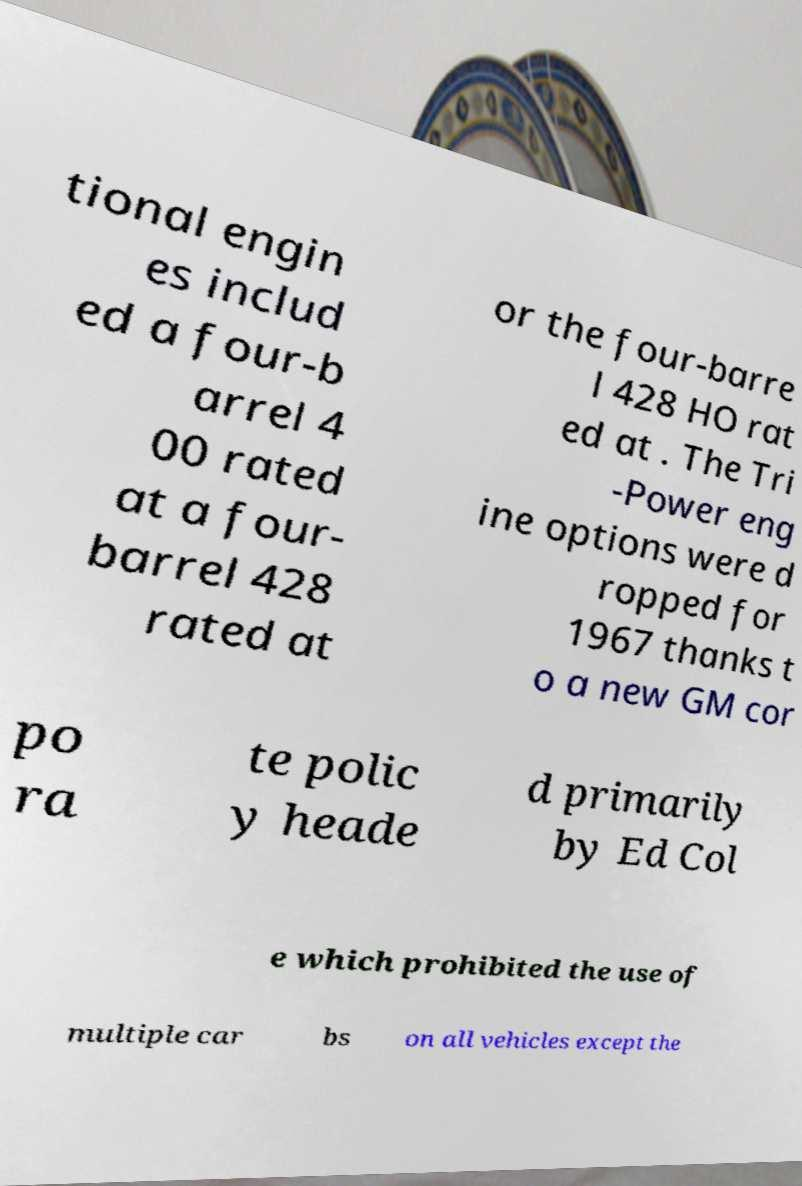Can you accurately transcribe the text from the provided image for me? tional engin es includ ed a four-b arrel 4 00 rated at a four- barrel 428 rated at or the four-barre l 428 HO rat ed at . The Tri -Power eng ine options were d ropped for 1967 thanks t o a new GM cor po ra te polic y heade d primarily by Ed Col e which prohibited the use of multiple car bs on all vehicles except the 